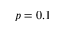<formula> <loc_0><loc_0><loc_500><loc_500>p = 0 . 1</formula> 